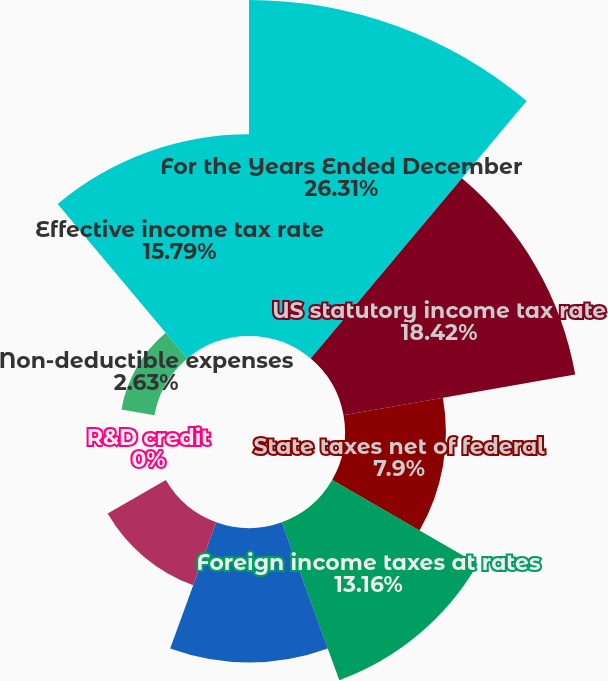<chart> <loc_0><loc_0><loc_500><loc_500><pie_chart><fcel>For the Years Ended December<fcel>US statutory income tax rate<fcel>State taxes net of federal<fcel>Foreign income taxes at rates<fcel>Tax benefit relating to<fcel>Tax benefit relating to US<fcel>R&D credit<fcel>Non-deductible expenses<fcel>Effective income tax rate<nl><fcel>26.31%<fcel>18.42%<fcel>7.9%<fcel>13.16%<fcel>10.53%<fcel>5.26%<fcel>0.0%<fcel>2.63%<fcel>15.79%<nl></chart> 